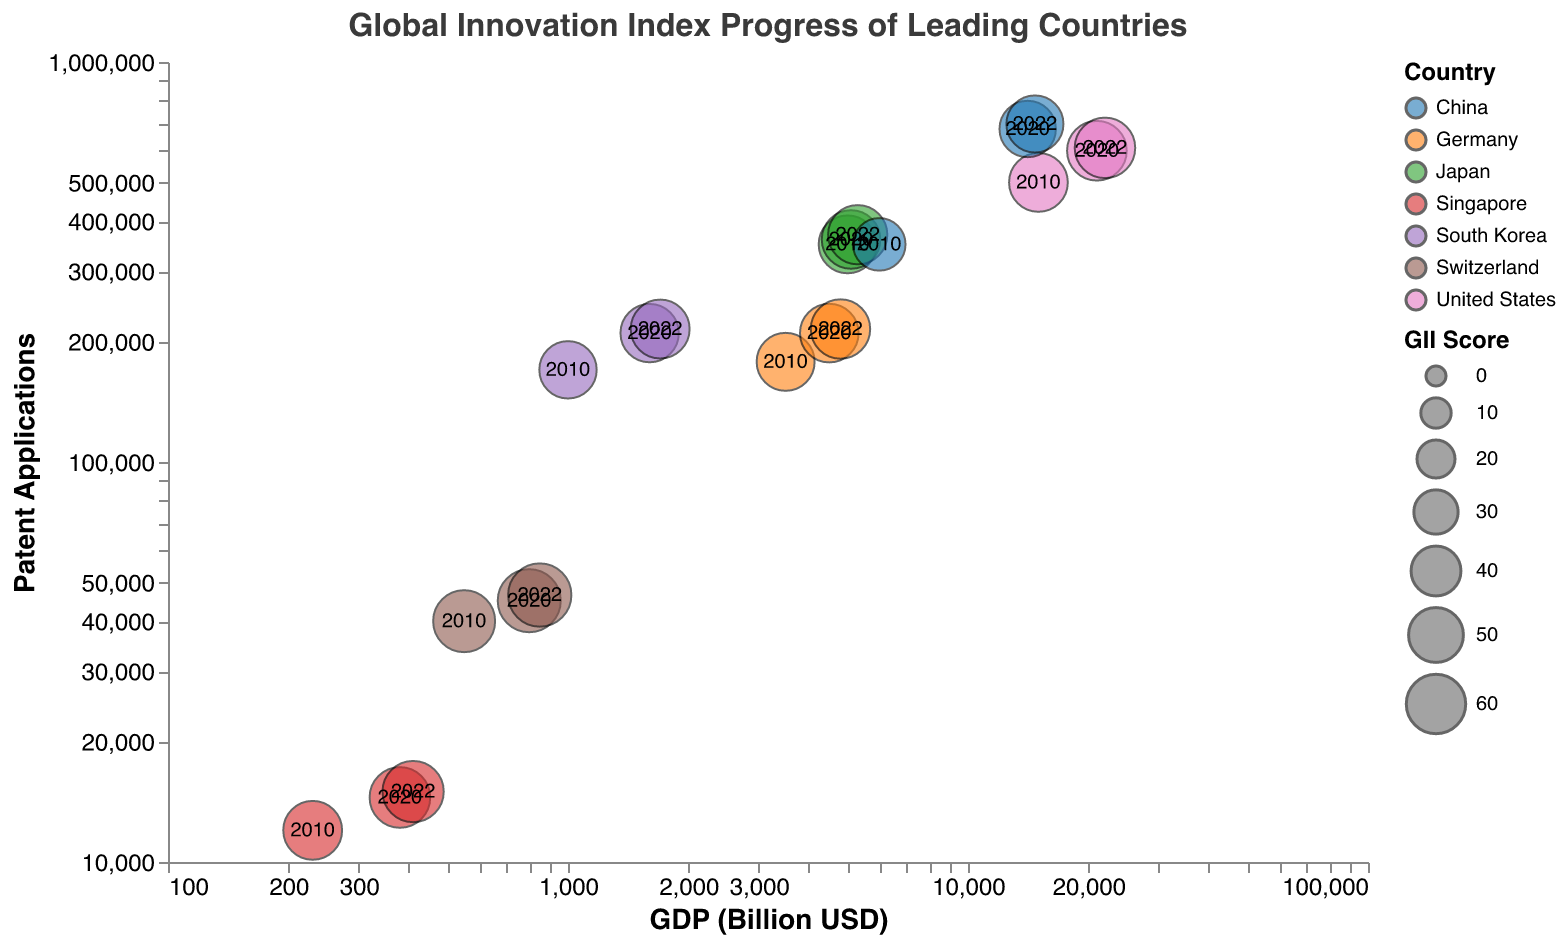What is the title of the chart? The title of the chart is located at the top and labels what the chart is about. The title is "Global Innovation Index Progress of Leading Countries," which sets the context for the data presented.
Answer: Global Innovation Index Progress of Leading Countries Which country had the highest GII Score in 2022? To find the highest GII Score in 2022, look at the bubbles representing 2022 for each country and identify the bubble with the largest size. Based on the figure, the largest GII Score bubble for 2022 belongs to Switzerland.
Answer: Switzerland What trend can be observed in China's patent applications from 2010 to 2022? To observe the trend, examine the bubbles representing China for the years 2010, 2020, and 2022. Note the increase in the y-axis (Patent Applications) for these years. From the data, China's patent applications increased from 350,000 in 2010 to 680,000 in 2020 and 700,000 in 2022, showing a significant upward trend.
Answer: Upward trend Which country has the smallest GDP in 2022, and what is its value? Examine the bubbles for 2022 and look at the x-axis representing GDP. The bubble closest to the left signifies the smallest GDP. This bubble corresponds to Singapore, which, in the data, has a GDP of 410 billion USD in 2022.
Answer: Singapore, 410 billion USD In 2020, which country had more patent applications, Japan or Germany? Compare the bubbles for Japan and Germany in 2020 on the y-axis, which represents Patent Applications. From the figure, Japan's 2020 bubble is higher on the y-axis than Germany's, indicating more patent applications.
Answer: Japan What do the bubble sizes represent? The bubble sizes vary and represent the GII Score for each country and year. Larger bubbles indicate higher GII Scores, showing the relative innovation index progress.
Answer: GII Score How has the GDP of South Korea changed from 2010 to 2022? To find the change in South Korea's GDP, compare the positions of South Korea's bubbles from 2010 to 2022 along the x-axis. In 2010, the GDP is at 1000 billion USD, and it has increased to 1700 billion USD by 2022, indicating a growth.
Answer: Increased Which country showed the most significant increase in GDP between 2010 and 2022? Compare the bubbles' positions on the x-axis from 2010 to 2022. China shows the largest horizontal shift from 6000 billion USD in 2010 to 14700 billion USD in 2022, indicating the most significant GDP increase.
Answer: China How does Switzerland's GII Score in 2022 compare to the other countries? To compare Switzerland's GII Score in 2022, focus on the bubble size for Switzerland in 2022 and compare it with other countries' bubble sizes for the same year. Switzerland appears to have the largest bubble, indicating the highest GII Score.
Answer: Highest What does the transparency of the bubbles allow you to see? The transparency of the bubbles allows overlapping bubbles to be distinguished easily, ensuring that data points that lie behind others are still visible, improving the clarity of the chart.
Answer: Overlapping details 